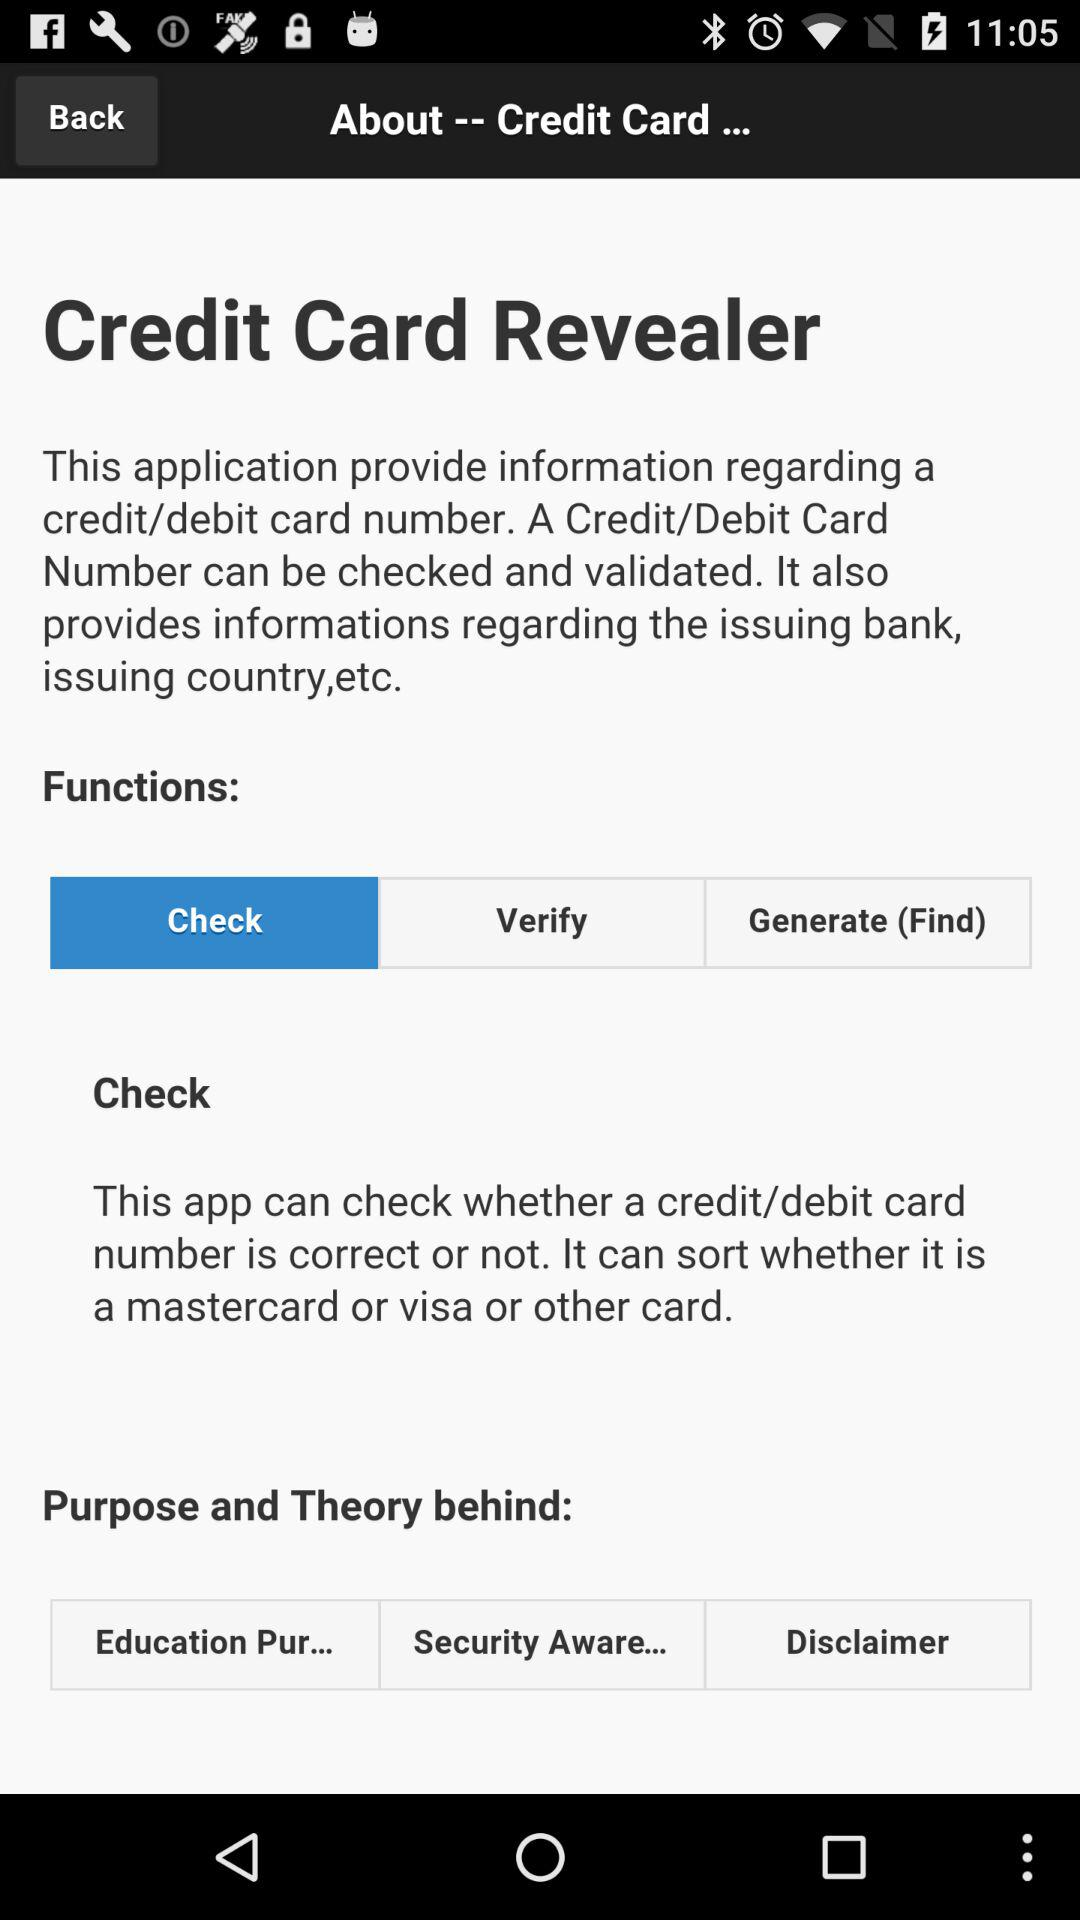How many functions are available?
Answer the question using a single word or phrase. 3 